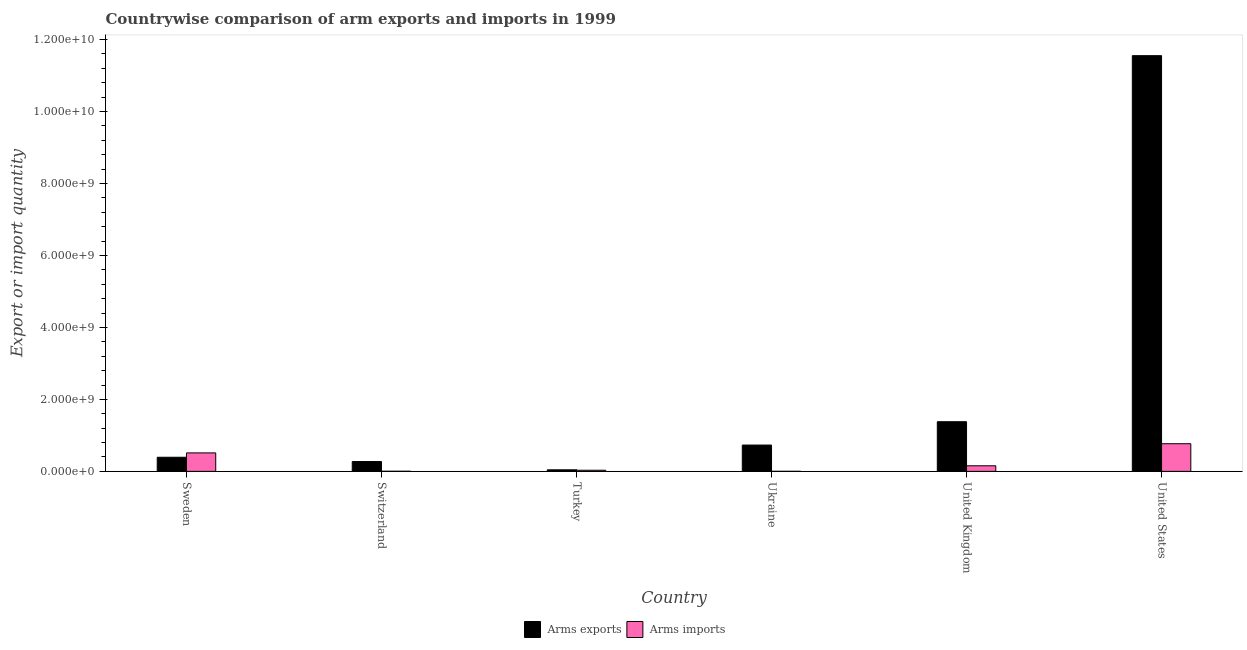How many different coloured bars are there?
Provide a succinct answer. 2. How many bars are there on the 6th tick from the right?
Ensure brevity in your answer.  2. What is the label of the 2nd group of bars from the left?
Offer a terse response. Switzerland. What is the arms imports in Ukraine?
Offer a very short reply. 1.00e+06. Across all countries, what is the maximum arms exports?
Provide a succinct answer. 1.16e+1. Across all countries, what is the minimum arms exports?
Keep it short and to the point. 4.30e+07. In which country was the arms imports minimum?
Offer a very short reply. Ukraine. What is the total arms exports in the graph?
Provide a succinct answer. 1.44e+1. What is the difference between the arms exports in Sweden and that in Switzerland?
Make the answer very short. 1.19e+08. What is the difference between the arms exports in United Kingdom and the arms imports in Switzerland?
Offer a terse response. 1.38e+09. What is the average arms imports per country?
Ensure brevity in your answer.  2.45e+08. What is the difference between the arms exports and arms imports in Sweden?
Your response must be concise. -1.21e+08. In how many countries, is the arms imports greater than 1200000000 ?
Offer a terse response. 0. What is the ratio of the arms imports in Switzerland to that in Turkey?
Offer a very short reply. 0.1. Is the arms imports in Sweden less than that in Ukraine?
Offer a very short reply. No. Is the difference between the arms imports in Ukraine and United States greater than the difference between the arms exports in Ukraine and United States?
Give a very brief answer. Yes. What is the difference between the highest and the second highest arms imports?
Offer a very short reply. 2.55e+08. What is the difference between the highest and the lowest arms imports?
Offer a terse response. 7.67e+08. In how many countries, is the arms imports greater than the average arms imports taken over all countries?
Offer a terse response. 2. Is the sum of the arms imports in Turkey and United States greater than the maximum arms exports across all countries?
Give a very brief answer. No. What does the 2nd bar from the left in Switzerland represents?
Provide a short and direct response. Arms imports. What does the 1st bar from the right in Sweden represents?
Provide a short and direct response. Arms imports. How many bars are there?
Your response must be concise. 12. Are all the bars in the graph horizontal?
Keep it short and to the point. No. How many countries are there in the graph?
Ensure brevity in your answer.  6. Are the values on the major ticks of Y-axis written in scientific E-notation?
Give a very brief answer. Yes. Does the graph contain grids?
Provide a short and direct response. No. How many legend labels are there?
Keep it short and to the point. 2. What is the title of the graph?
Ensure brevity in your answer.  Countrywise comparison of arm exports and imports in 1999. Does "Highest 20% of population" appear as one of the legend labels in the graph?
Give a very brief answer. No. What is the label or title of the Y-axis?
Offer a terse response. Export or import quantity. What is the Export or import quantity of Arms exports in Sweden?
Your response must be concise. 3.92e+08. What is the Export or import quantity in Arms imports in Sweden?
Give a very brief answer. 5.13e+08. What is the Export or import quantity in Arms exports in Switzerland?
Provide a succinct answer. 2.73e+08. What is the Export or import quantity of Arms imports in Switzerland?
Ensure brevity in your answer.  3.00e+06. What is the Export or import quantity of Arms exports in Turkey?
Offer a terse response. 4.30e+07. What is the Export or import quantity of Arms imports in Turkey?
Your answer should be compact. 3.10e+07. What is the Export or import quantity in Arms exports in Ukraine?
Your response must be concise. 7.31e+08. What is the Export or import quantity in Arms exports in United Kingdom?
Your answer should be compact. 1.38e+09. What is the Export or import quantity in Arms imports in United Kingdom?
Keep it short and to the point. 1.55e+08. What is the Export or import quantity in Arms exports in United States?
Keep it short and to the point. 1.16e+1. What is the Export or import quantity in Arms imports in United States?
Your answer should be very brief. 7.68e+08. Across all countries, what is the maximum Export or import quantity of Arms exports?
Provide a short and direct response. 1.16e+1. Across all countries, what is the maximum Export or import quantity in Arms imports?
Provide a short and direct response. 7.68e+08. Across all countries, what is the minimum Export or import quantity of Arms exports?
Provide a succinct answer. 4.30e+07. What is the total Export or import quantity in Arms exports in the graph?
Offer a terse response. 1.44e+1. What is the total Export or import quantity in Arms imports in the graph?
Offer a terse response. 1.47e+09. What is the difference between the Export or import quantity of Arms exports in Sweden and that in Switzerland?
Provide a succinct answer. 1.19e+08. What is the difference between the Export or import quantity in Arms imports in Sweden and that in Switzerland?
Offer a very short reply. 5.10e+08. What is the difference between the Export or import quantity of Arms exports in Sweden and that in Turkey?
Your answer should be compact. 3.49e+08. What is the difference between the Export or import quantity of Arms imports in Sweden and that in Turkey?
Ensure brevity in your answer.  4.82e+08. What is the difference between the Export or import quantity in Arms exports in Sweden and that in Ukraine?
Provide a succinct answer. -3.39e+08. What is the difference between the Export or import quantity in Arms imports in Sweden and that in Ukraine?
Provide a short and direct response. 5.12e+08. What is the difference between the Export or import quantity in Arms exports in Sweden and that in United Kingdom?
Your answer should be very brief. -9.88e+08. What is the difference between the Export or import quantity in Arms imports in Sweden and that in United Kingdom?
Your answer should be very brief. 3.58e+08. What is the difference between the Export or import quantity in Arms exports in Sweden and that in United States?
Provide a succinct answer. -1.12e+1. What is the difference between the Export or import quantity of Arms imports in Sweden and that in United States?
Your answer should be very brief. -2.55e+08. What is the difference between the Export or import quantity of Arms exports in Switzerland and that in Turkey?
Offer a very short reply. 2.30e+08. What is the difference between the Export or import quantity in Arms imports in Switzerland and that in Turkey?
Provide a succinct answer. -2.80e+07. What is the difference between the Export or import quantity in Arms exports in Switzerland and that in Ukraine?
Your answer should be very brief. -4.58e+08. What is the difference between the Export or import quantity of Arms imports in Switzerland and that in Ukraine?
Offer a terse response. 2.00e+06. What is the difference between the Export or import quantity in Arms exports in Switzerland and that in United Kingdom?
Offer a terse response. -1.11e+09. What is the difference between the Export or import quantity of Arms imports in Switzerland and that in United Kingdom?
Make the answer very short. -1.52e+08. What is the difference between the Export or import quantity in Arms exports in Switzerland and that in United States?
Make the answer very short. -1.13e+1. What is the difference between the Export or import quantity of Arms imports in Switzerland and that in United States?
Your response must be concise. -7.65e+08. What is the difference between the Export or import quantity of Arms exports in Turkey and that in Ukraine?
Your response must be concise. -6.88e+08. What is the difference between the Export or import quantity of Arms imports in Turkey and that in Ukraine?
Make the answer very short. 3.00e+07. What is the difference between the Export or import quantity of Arms exports in Turkey and that in United Kingdom?
Keep it short and to the point. -1.34e+09. What is the difference between the Export or import quantity of Arms imports in Turkey and that in United Kingdom?
Keep it short and to the point. -1.24e+08. What is the difference between the Export or import quantity in Arms exports in Turkey and that in United States?
Your response must be concise. -1.15e+1. What is the difference between the Export or import quantity in Arms imports in Turkey and that in United States?
Keep it short and to the point. -7.37e+08. What is the difference between the Export or import quantity of Arms exports in Ukraine and that in United Kingdom?
Offer a very short reply. -6.49e+08. What is the difference between the Export or import quantity in Arms imports in Ukraine and that in United Kingdom?
Ensure brevity in your answer.  -1.54e+08. What is the difference between the Export or import quantity in Arms exports in Ukraine and that in United States?
Provide a succinct answer. -1.08e+1. What is the difference between the Export or import quantity in Arms imports in Ukraine and that in United States?
Offer a terse response. -7.67e+08. What is the difference between the Export or import quantity of Arms exports in United Kingdom and that in United States?
Keep it short and to the point. -1.02e+1. What is the difference between the Export or import quantity in Arms imports in United Kingdom and that in United States?
Ensure brevity in your answer.  -6.13e+08. What is the difference between the Export or import quantity in Arms exports in Sweden and the Export or import quantity in Arms imports in Switzerland?
Offer a terse response. 3.89e+08. What is the difference between the Export or import quantity in Arms exports in Sweden and the Export or import quantity in Arms imports in Turkey?
Give a very brief answer. 3.61e+08. What is the difference between the Export or import quantity of Arms exports in Sweden and the Export or import quantity of Arms imports in Ukraine?
Provide a succinct answer. 3.91e+08. What is the difference between the Export or import quantity in Arms exports in Sweden and the Export or import quantity in Arms imports in United Kingdom?
Give a very brief answer. 2.37e+08. What is the difference between the Export or import quantity of Arms exports in Sweden and the Export or import quantity of Arms imports in United States?
Give a very brief answer. -3.76e+08. What is the difference between the Export or import quantity in Arms exports in Switzerland and the Export or import quantity in Arms imports in Turkey?
Your answer should be very brief. 2.42e+08. What is the difference between the Export or import quantity of Arms exports in Switzerland and the Export or import quantity of Arms imports in Ukraine?
Keep it short and to the point. 2.72e+08. What is the difference between the Export or import quantity in Arms exports in Switzerland and the Export or import quantity in Arms imports in United Kingdom?
Offer a terse response. 1.18e+08. What is the difference between the Export or import quantity of Arms exports in Switzerland and the Export or import quantity of Arms imports in United States?
Keep it short and to the point. -4.95e+08. What is the difference between the Export or import quantity in Arms exports in Turkey and the Export or import quantity in Arms imports in Ukraine?
Your answer should be compact. 4.20e+07. What is the difference between the Export or import quantity of Arms exports in Turkey and the Export or import quantity of Arms imports in United Kingdom?
Give a very brief answer. -1.12e+08. What is the difference between the Export or import quantity in Arms exports in Turkey and the Export or import quantity in Arms imports in United States?
Keep it short and to the point. -7.25e+08. What is the difference between the Export or import quantity in Arms exports in Ukraine and the Export or import quantity in Arms imports in United Kingdom?
Your answer should be compact. 5.76e+08. What is the difference between the Export or import quantity in Arms exports in Ukraine and the Export or import quantity in Arms imports in United States?
Ensure brevity in your answer.  -3.70e+07. What is the difference between the Export or import quantity of Arms exports in United Kingdom and the Export or import quantity of Arms imports in United States?
Make the answer very short. 6.12e+08. What is the average Export or import quantity of Arms exports per country?
Ensure brevity in your answer.  2.40e+09. What is the average Export or import quantity in Arms imports per country?
Make the answer very short. 2.45e+08. What is the difference between the Export or import quantity in Arms exports and Export or import quantity in Arms imports in Sweden?
Your answer should be compact. -1.21e+08. What is the difference between the Export or import quantity of Arms exports and Export or import quantity of Arms imports in Switzerland?
Keep it short and to the point. 2.70e+08. What is the difference between the Export or import quantity of Arms exports and Export or import quantity of Arms imports in Turkey?
Provide a succinct answer. 1.20e+07. What is the difference between the Export or import quantity in Arms exports and Export or import quantity in Arms imports in Ukraine?
Offer a very short reply. 7.30e+08. What is the difference between the Export or import quantity in Arms exports and Export or import quantity in Arms imports in United Kingdom?
Make the answer very short. 1.22e+09. What is the difference between the Export or import quantity in Arms exports and Export or import quantity in Arms imports in United States?
Your answer should be compact. 1.08e+1. What is the ratio of the Export or import quantity in Arms exports in Sweden to that in Switzerland?
Keep it short and to the point. 1.44. What is the ratio of the Export or import quantity in Arms imports in Sweden to that in Switzerland?
Give a very brief answer. 171. What is the ratio of the Export or import quantity in Arms exports in Sweden to that in Turkey?
Provide a succinct answer. 9.12. What is the ratio of the Export or import quantity of Arms imports in Sweden to that in Turkey?
Provide a short and direct response. 16.55. What is the ratio of the Export or import quantity in Arms exports in Sweden to that in Ukraine?
Keep it short and to the point. 0.54. What is the ratio of the Export or import quantity of Arms imports in Sweden to that in Ukraine?
Keep it short and to the point. 513. What is the ratio of the Export or import quantity in Arms exports in Sweden to that in United Kingdom?
Your response must be concise. 0.28. What is the ratio of the Export or import quantity in Arms imports in Sweden to that in United Kingdom?
Make the answer very short. 3.31. What is the ratio of the Export or import quantity of Arms exports in Sweden to that in United States?
Ensure brevity in your answer.  0.03. What is the ratio of the Export or import quantity in Arms imports in Sweden to that in United States?
Your answer should be compact. 0.67. What is the ratio of the Export or import quantity in Arms exports in Switzerland to that in Turkey?
Make the answer very short. 6.35. What is the ratio of the Export or import quantity in Arms imports in Switzerland to that in Turkey?
Offer a terse response. 0.1. What is the ratio of the Export or import quantity in Arms exports in Switzerland to that in Ukraine?
Your response must be concise. 0.37. What is the ratio of the Export or import quantity in Arms imports in Switzerland to that in Ukraine?
Provide a short and direct response. 3. What is the ratio of the Export or import quantity of Arms exports in Switzerland to that in United Kingdom?
Your response must be concise. 0.2. What is the ratio of the Export or import quantity of Arms imports in Switzerland to that in United Kingdom?
Provide a succinct answer. 0.02. What is the ratio of the Export or import quantity in Arms exports in Switzerland to that in United States?
Your answer should be very brief. 0.02. What is the ratio of the Export or import quantity of Arms imports in Switzerland to that in United States?
Ensure brevity in your answer.  0. What is the ratio of the Export or import quantity of Arms exports in Turkey to that in Ukraine?
Provide a short and direct response. 0.06. What is the ratio of the Export or import quantity of Arms exports in Turkey to that in United Kingdom?
Ensure brevity in your answer.  0.03. What is the ratio of the Export or import quantity in Arms imports in Turkey to that in United Kingdom?
Keep it short and to the point. 0.2. What is the ratio of the Export or import quantity in Arms exports in Turkey to that in United States?
Make the answer very short. 0. What is the ratio of the Export or import quantity of Arms imports in Turkey to that in United States?
Your response must be concise. 0.04. What is the ratio of the Export or import quantity in Arms exports in Ukraine to that in United Kingdom?
Keep it short and to the point. 0.53. What is the ratio of the Export or import quantity in Arms imports in Ukraine to that in United Kingdom?
Ensure brevity in your answer.  0.01. What is the ratio of the Export or import quantity in Arms exports in Ukraine to that in United States?
Provide a short and direct response. 0.06. What is the ratio of the Export or import quantity in Arms imports in Ukraine to that in United States?
Keep it short and to the point. 0. What is the ratio of the Export or import quantity of Arms exports in United Kingdom to that in United States?
Provide a succinct answer. 0.12. What is the ratio of the Export or import quantity in Arms imports in United Kingdom to that in United States?
Offer a very short reply. 0.2. What is the difference between the highest and the second highest Export or import quantity of Arms exports?
Offer a very short reply. 1.02e+1. What is the difference between the highest and the second highest Export or import quantity in Arms imports?
Offer a very short reply. 2.55e+08. What is the difference between the highest and the lowest Export or import quantity of Arms exports?
Keep it short and to the point. 1.15e+1. What is the difference between the highest and the lowest Export or import quantity of Arms imports?
Your response must be concise. 7.67e+08. 